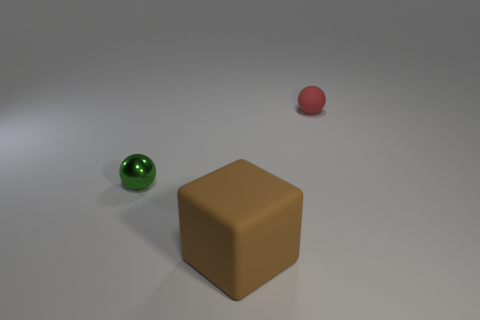Do the rubber ball that is behind the brown thing and the matte cube have the same color? No, they do not have the same color. The rubber ball appears to be red while the matte cube has a brown color. Despite the similar saturation and lighting conditions, you can clearly see the color distinction between the two objects. 